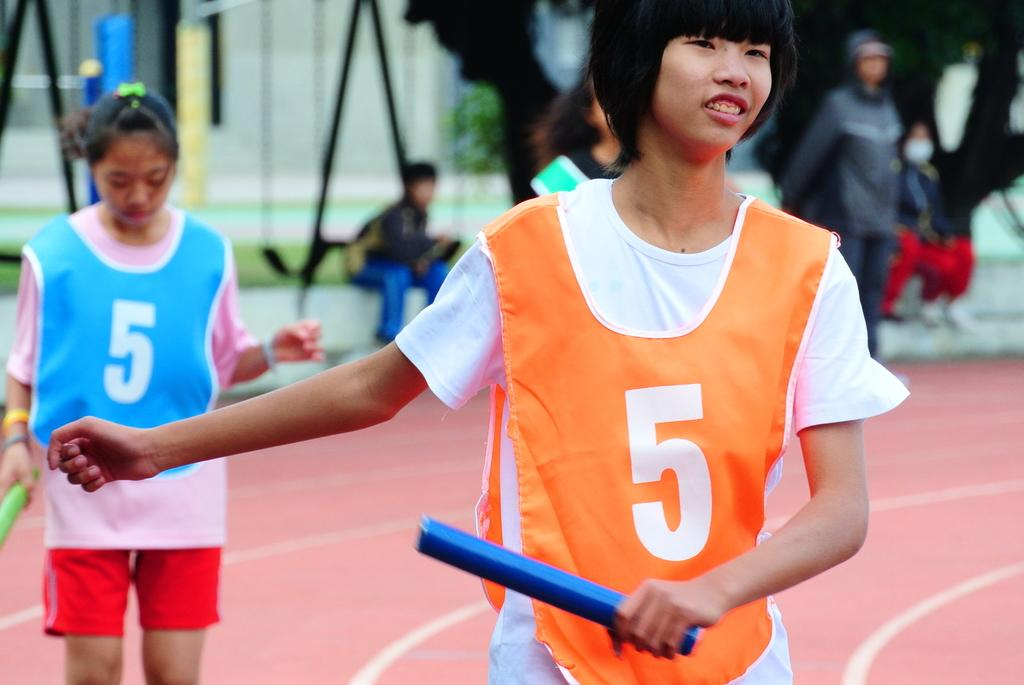What is the main subject of the image? There is a person in the image. What is the person holding in the image? The person is holding something. Can you describe the person's clothing in the image? The person is wearing a white and orange dress. Are there any other people visible in the image? Yes, there are people visible in the background of the image. How would you describe the quality of the image? The image is blurry. What type of nail can be seen in the person's hand in the image? There is no nail visible in the person's hand in the image. Can you tell me how many bananas are on the bed in the image? There is no bed or bananas present in the image. 